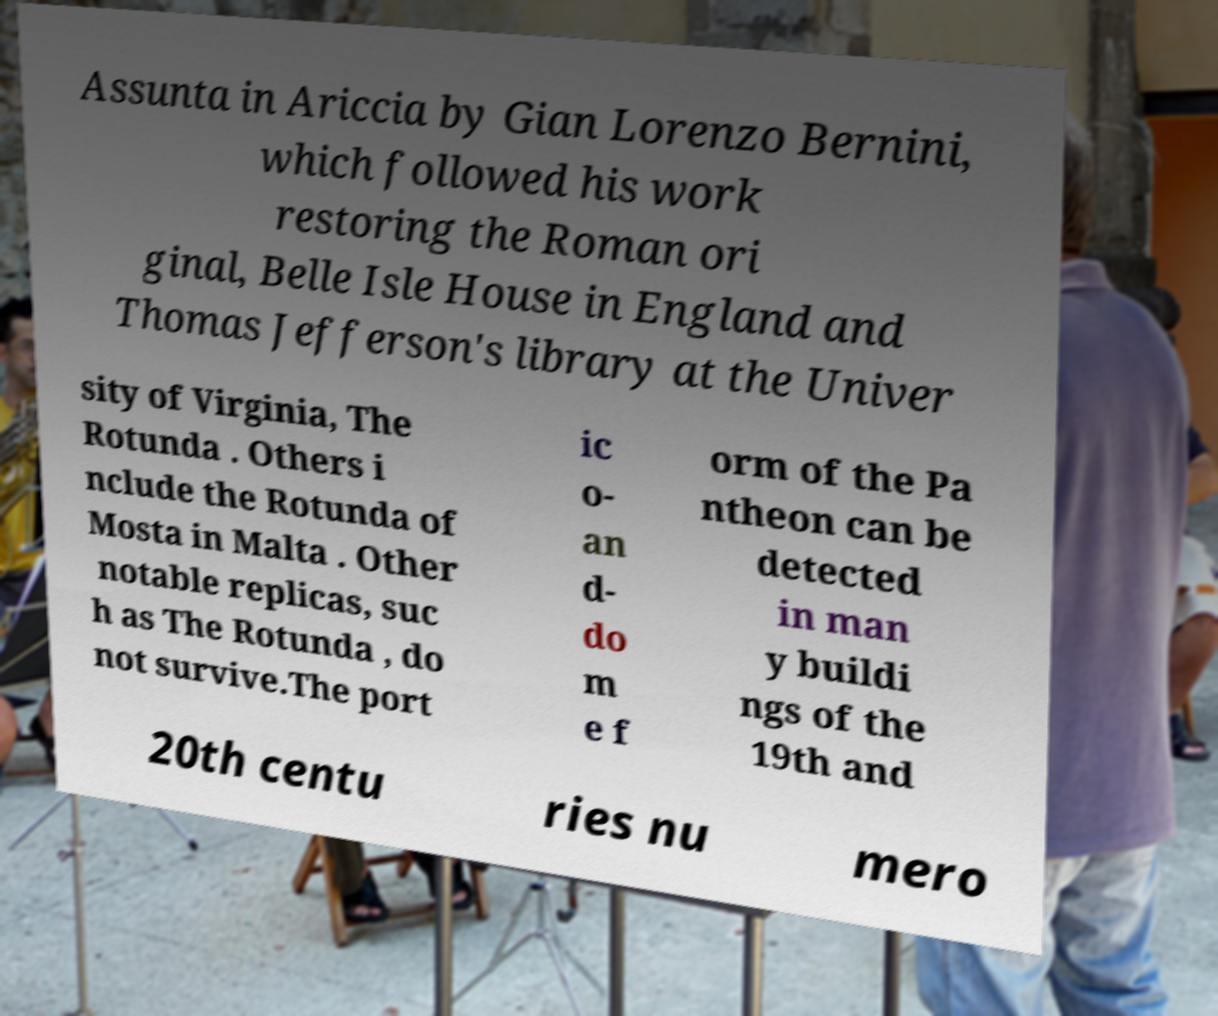I need the written content from this picture converted into text. Can you do that? Assunta in Ariccia by Gian Lorenzo Bernini, which followed his work restoring the Roman ori ginal, Belle Isle House in England and Thomas Jefferson's library at the Univer sity of Virginia, The Rotunda . Others i nclude the Rotunda of Mosta in Malta . Other notable replicas, suc h as The Rotunda , do not survive.The port ic o- an d- do m e f orm of the Pa ntheon can be detected in man y buildi ngs of the 19th and 20th centu ries nu mero 